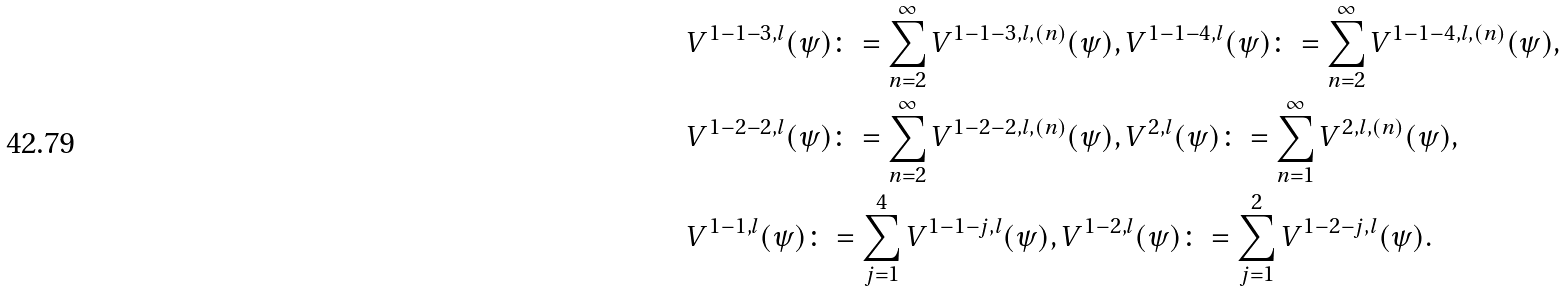Convert formula to latex. <formula><loc_0><loc_0><loc_500><loc_500>& V ^ { 1 - 1 - 3 , l } ( \psi ) \colon = \sum _ { n = 2 } ^ { \infty } V ^ { 1 - 1 - 3 , l , ( n ) } ( \psi ) , V ^ { 1 - 1 - 4 , l } ( \psi ) \colon = \sum _ { n = 2 } ^ { \infty } V ^ { 1 - 1 - 4 , l , ( n ) } ( \psi ) , \\ & V ^ { 1 - 2 - 2 , l } ( \psi ) \colon = \sum _ { n = 2 } ^ { \infty } V ^ { 1 - 2 - 2 , l , ( n ) } ( \psi ) , V ^ { 2 , l } ( \psi ) \colon = \sum _ { n = 1 } ^ { \infty } V ^ { 2 , l , ( n ) } ( \psi ) , \\ & V ^ { 1 - 1 , l } ( \psi ) \colon = \sum _ { j = 1 } ^ { 4 } V ^ { 1 - 1 - j , l } ( \psi ) , V ^ { 1 - 2 , l } ( \psi ) \colon = \sum _ { j = 1 } ^ { 2 } V ^ { 1 - 2 - j , l } ( \psi ) .</formula> 